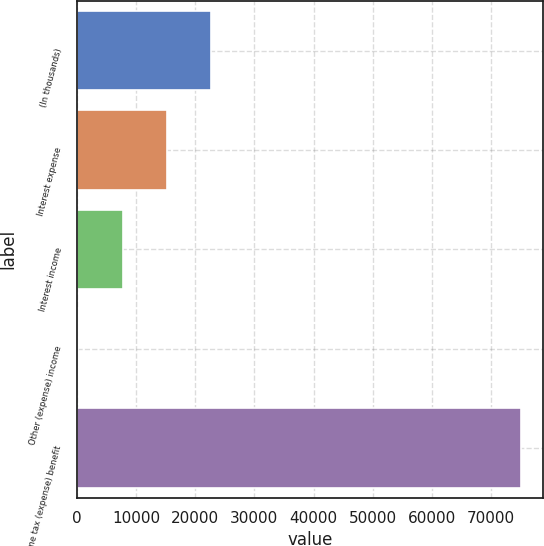Convert chart. <chart><loc_0><loc_0><loc_500><loc_500><bar_chart><fcel>(In thousands)<fcel>Interest expense<fcel>Interest income<fcel>Other (expense) income<fcel>Income tax (expense) benefit<nl><fcel>22696.4<fcel>15215.6<fcel>7734.8<fcel>254<fcel>75062<nl></chart> 